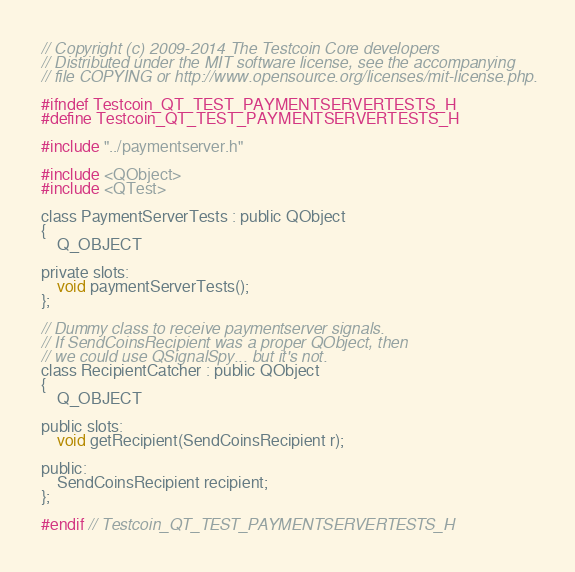Convert code to text. <code><loc_0><loc_0><loc_500><loc_500><_C_>// Copyright (c) 2009-2014 The Testcoin Core developers
// Distributed under the MIT software license, see the accompanying
// file COPYING or http://www.opensource.org/licenses/mit-license.php.

#ifndef Testcoin_QT_TEST_PAYMENTSERVERTESTS_H
#define Testcoin_QT_TEST_PAYMENTSERVERTESTS_H

#include "../paymentserver.h"

#include <QObject>
#include <QTest>

class PaymentServerTests : public QObject
{
    Q_OBJECT

private slots:
    void paymentServerTests();
};

// Dummy class to receive paymentserver signals.
// If SendCoinsRecipient was a proper QObject, then
// we could use QSignalSpy... but it's not.
class RecipientCatcher : public QObject
{
    Q_OBJECT

public slots:
    void getRecipient(SendCoinsRecipient r);

public:
    SendCoinsRecipient recipient;
};

#endif // Testcoin_QT_TEST_PAYMENTSERVERTESTS_H
</code> 